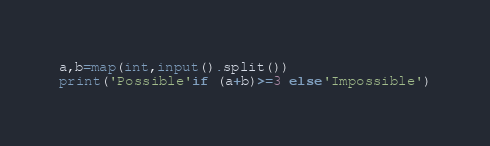<code> <loc_0><loc_0><loc_500><loc_500><_Python_>a,b=map(int,input().split())
print('Possible'if (a+b)>=3 else'Impossible')</code> 